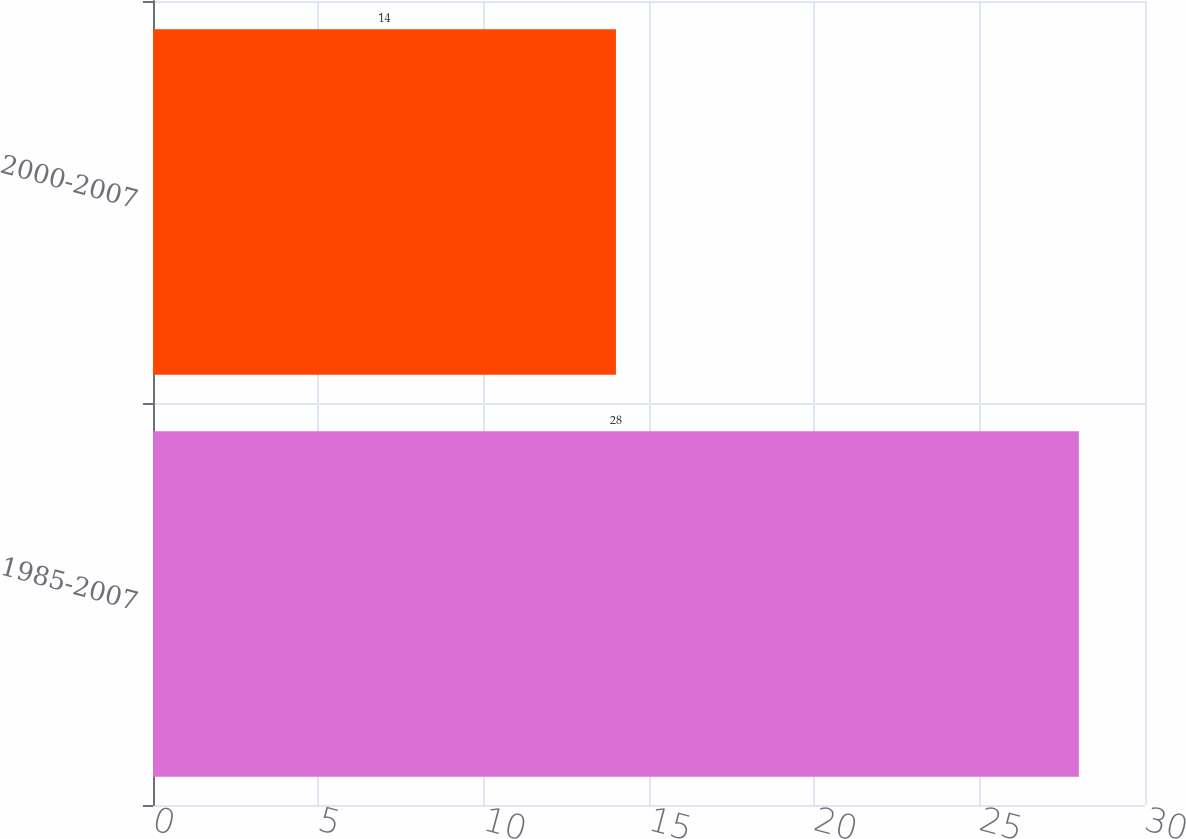Convert chart to OTSL. <chart><loc_0><loc_0><loc_500><loc_500><bar_chart><fcel>1985-2007<fcel>2000-2007<nl><fcel>28<fcel>14<nl></chart> 